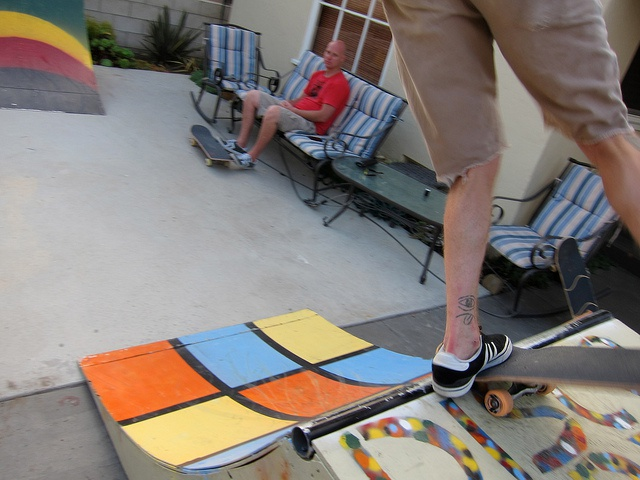Describe the objects in this image and their specific colors. I can see people in teal, gray, maroon, and black tones, chair in teal, black, and gray tones, bench in teal, gray, black, and darkgray tones, people in teal, gray, brown, and maroon tones, and dining table in teal, black, gray, and purple tones in this image. 